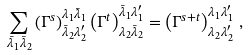<formula> <loc_0><loc_0><loc_500><loc_500>\sum _ { \bar { \lambda } _ { 1 } \bar { \lambda } _ { 2 } } \left ( \Gamma ^ { s } \right ) ^ { \lambda _ { 1 } \bar { \lambda } _ { 1 } } _ { \bar { \lambda } _ { 2 } \lambda _ { 2 } ^ { \prime } } \left ( \Gamma ^ { t } \right ) ^ { \bar { \lambda } _ { 1 } \lambda _ { 1 } ^ { \prime } } _ { \lambda _ { 2 } \bar { \lambda } _ { 2 } } = \left ( \Gamma ^ { s + t } \right ) ^ { \lambda _ { 1 } \lambda _ { 1 } ^ { \prime } } _ { \lambda _ { 2 } \lambda _ { 2 } ^ { \prime } } \, ,</formula> 